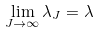Convert formula to latex. <formula><loc_0><loc_0><loc_500><loc_500>\lim _ { J \to \infty } \lambda _ { J } = \lambda</formula> 